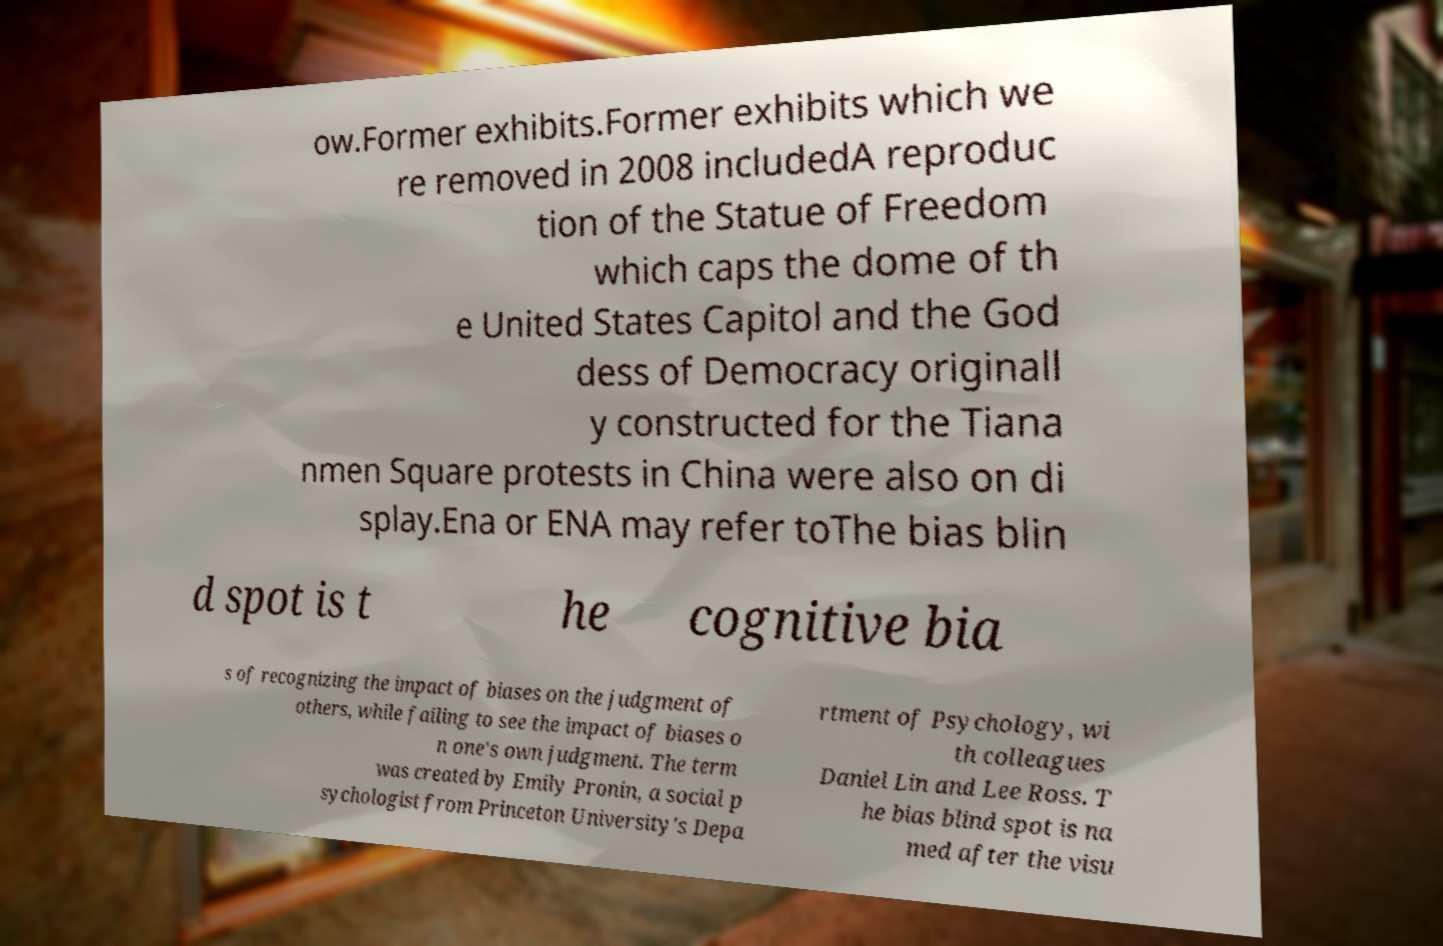For documentation purposes, I need the text within this image transcribed. Could you provide that? ow.Former exhibits.Former exhibits which we re removed in 2008 includedA reproduc tion of the Statue of Freedom which caps the dome of th e United States Capitol and the God dess of Democracy originall y constructed for the Tiana nmen Square protests in China were also on di splay.Ena or ENA may refer toThe bias blin d spot is t he cognitive bia s of recognizing the impact of biases on the judgment of others, while failing to see the impact of biases o n one's own judgment. The term was created by Emily Pronin, a social p sychologist from Princeton University's Depa rtment of Psychology, wi th colleagues Daniel Lin and Lee Ross. T he bias blind spot is na med after the visu 